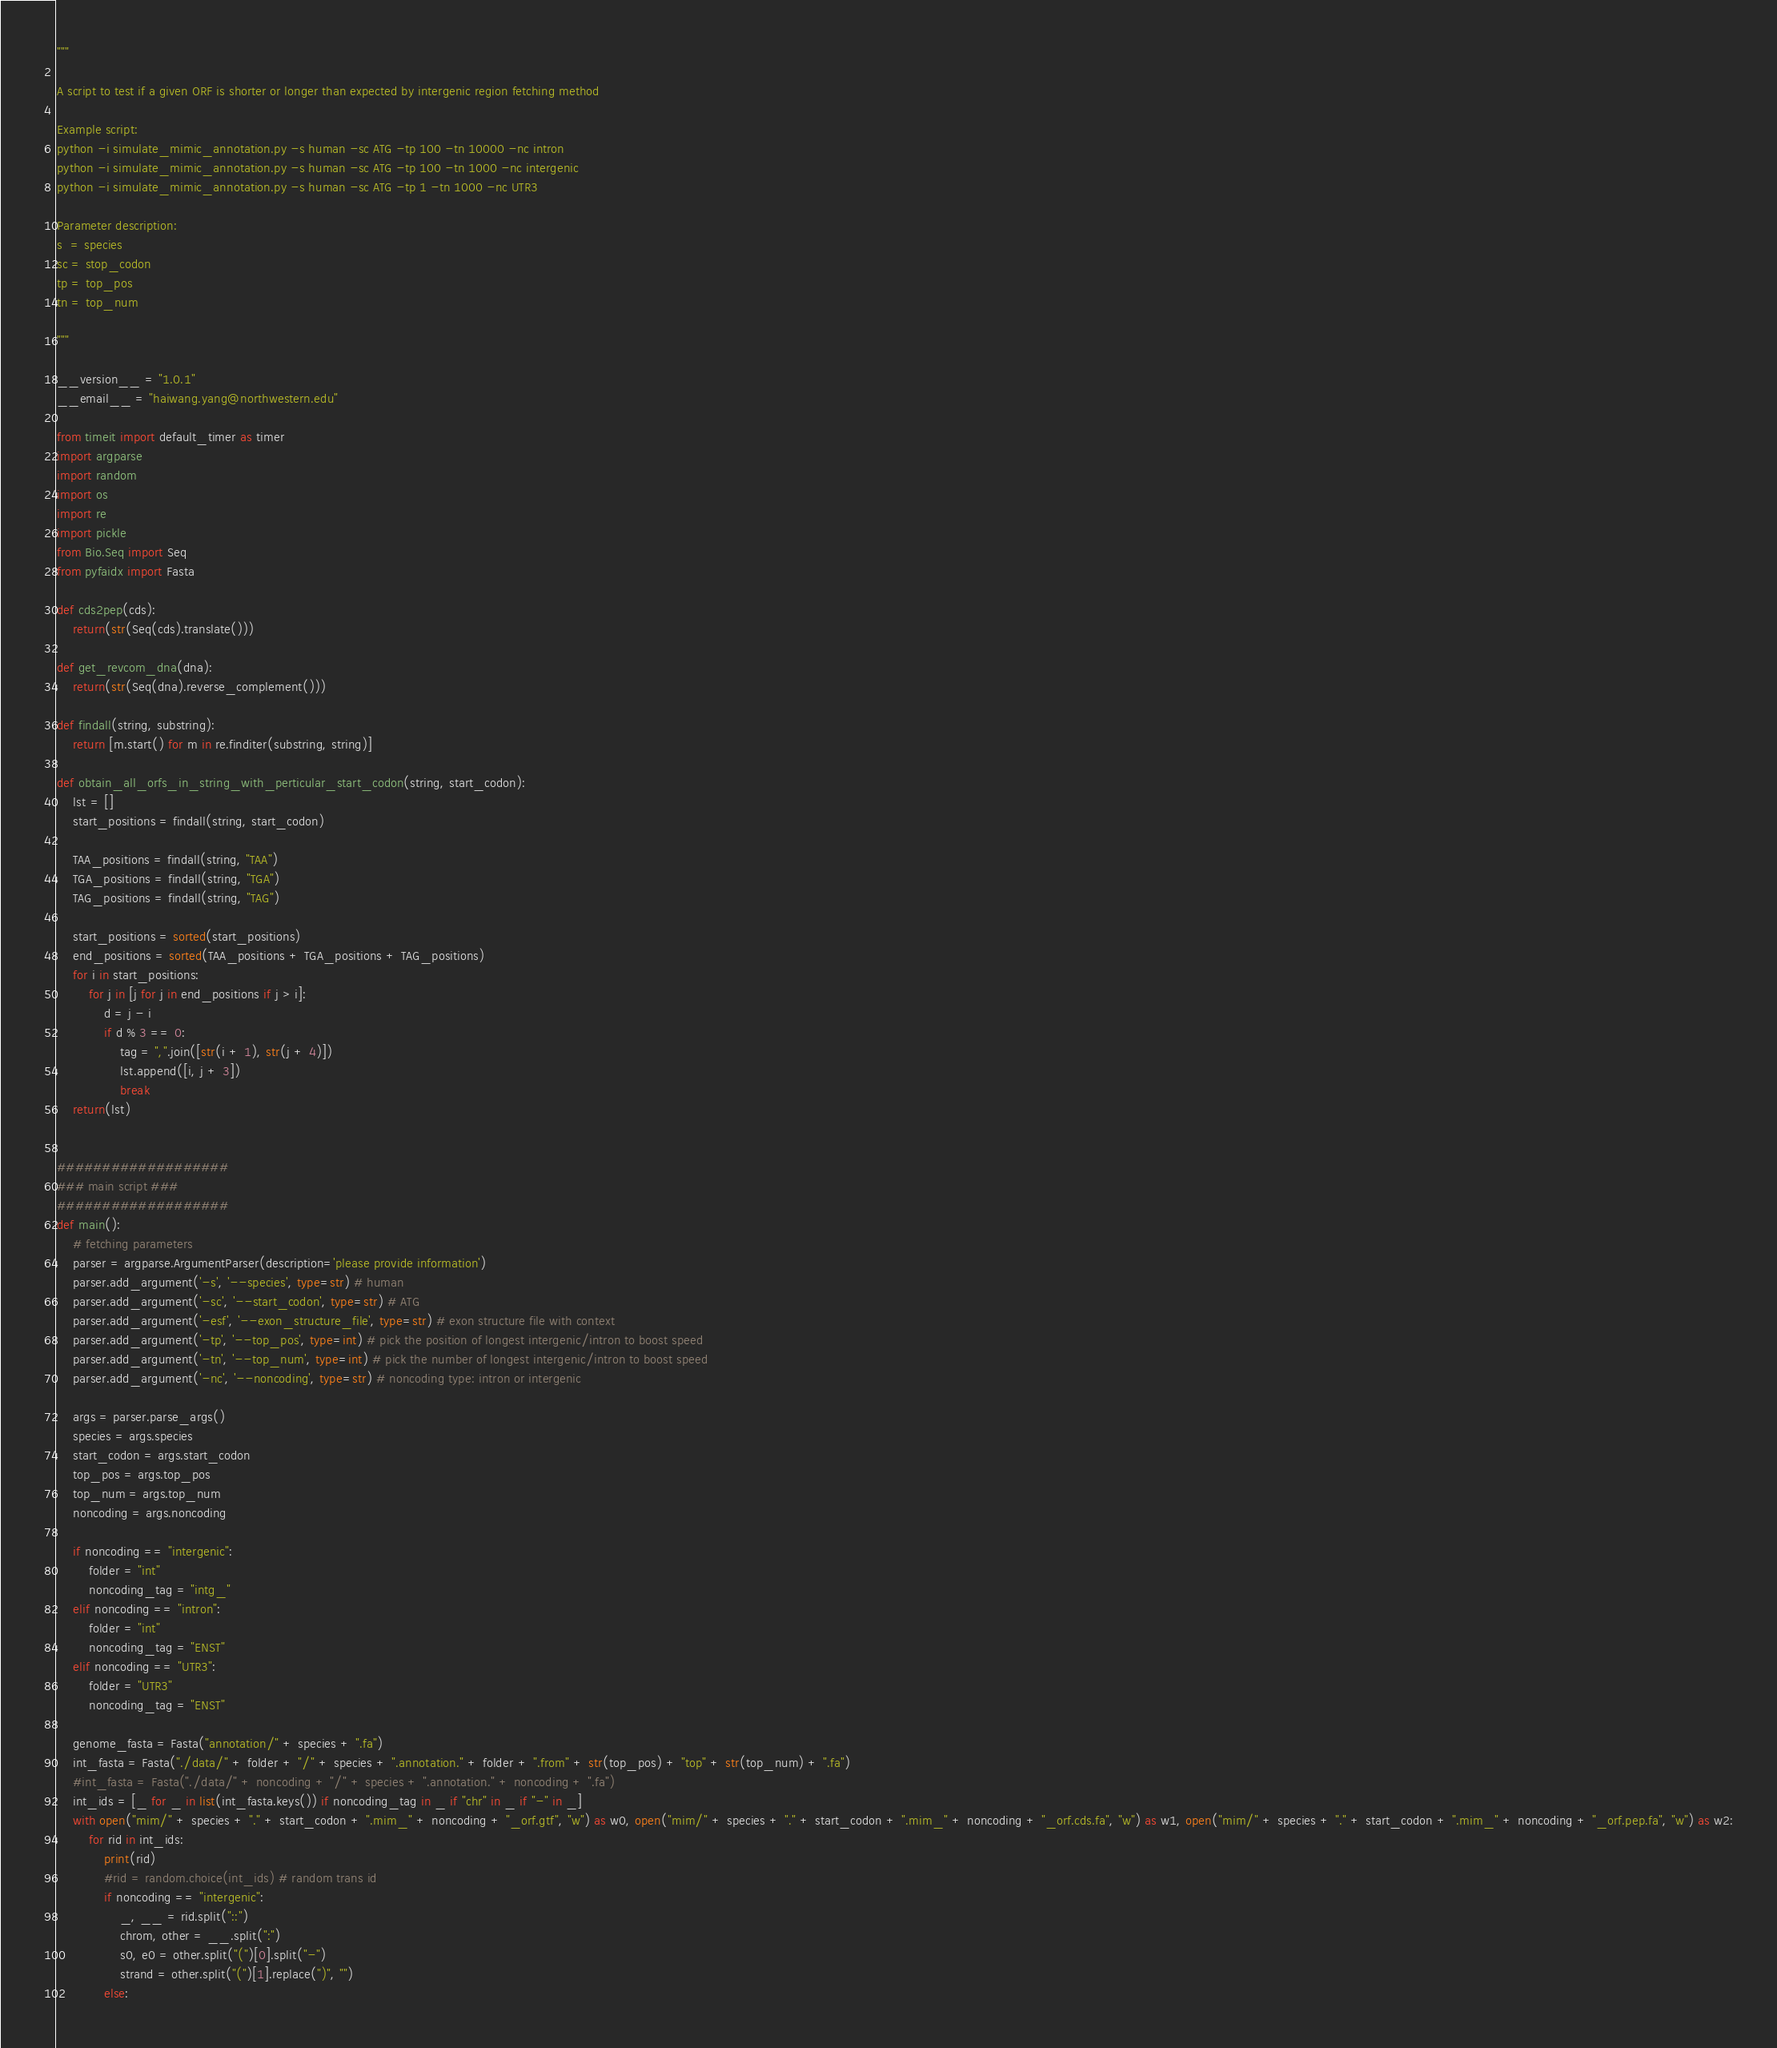Convert code to text. <code><loc_0><loc_0><loc_500><loc_500><_Python_>"""

A script to test if a given ORF is shorter or longer than expected by intergenic region fetching method

Example script:
python -i simulate_mimic_annotation.py -s human -sc ATG -tp 100 -tn 10000 -nc intron
python -i simulate_mimic_annotation.py -s human -sc ATG -tp 100 -tn 1000 -nc intergenic
python -i simulate_mimic_annotation.py -s human -sc ATG -tp 1 -tn 1000 -nc UTR3

Parameter description:
s  = species
sc = stop_codon
tp = top_pos
tn = top_num

"""

__version__ = "1.0.1"
__email__ = "haiwang.yang@northwestern.edu"

from timeit import default_timer as timer
import argparse
import random
import os
import re
import pickle
from Bio.Seq import Seq
from pyfaidx import Fasta

def cds2pep(cds):
    return(str(Seq(cds).translate()))

def get_revcom_dna(dna):
    return(str(Seq(dna).reverse_complement()))

def findall(string, substring):
    return [m.start() for m in re.finditer(substring, string)]

def obtain_all_orfs_in_string_with_perticular_start_codon(string, start_codon):
    lst = []
    start_positions = findall(string, start_codon)

    TAA_positions = findall(string, "TAA")
    TGA_positions = findall(string, "TGA")
    TAG_positions = findall(string, "TAG")

    start_positions = sorted(start_positions)
    end_positions = sorted(TAA_positions + TGA_positions + TAG_positions)
    for i in start_positions:
        for j in [j for j in end_positions if j > i]:
            d = j - i
            if d % 3 == 0:
                tag = ",".join([str(i + 1), str(j + 4)])
                lst.append([i, j + 3])
                break
    return(lst)


###################
### main script ###
###################
def main():
    # fetching parameters
    parser = argparse.ArgumentParser(description='please provide information')
    parser.add_argument('-s', '--species', type=str) # human
    parser.add_argument('-sc', '--start_codon', type=str) # ATG
    parser.add_argument('-esf', '--exon_structure_file', type=str) # exon structure file with context
    parser.add_argument('-tp', '--top_pos', type=int) # pick the position of longest intergenic/intron to boost speed
    parser.add_argument('-tn', '--top_num', type=int) # pick the number of longest intergenic/intron to boost speed
    parser.add_argument('-nc', '--noncoding', type=str) # noncoding type: intron or intergenic

    args = parser.parse_args()
    species = args.species
    start_codon = args.start_codon
    top_pos = args.top_pos
    top_num = args.top_num
    noncoding = args.noncoding

    if noncoding == "intergenic":
        folder = "int"
        noncoding_tag = "intg_"
    elif noncoding == "intron":
        folder = "int"
        noncoding_tag = "ENST"
    elif noncoding == "UTR3":
        folder = "UTR3"
        noncoding_tag = "ENST"

    genome_fasta = Fasta("annotation/" + species + ".fa")
    int_fasta = Fasta("./data/" + folder + "/" + species + ".annotation." + folder + ".from" + str(top_pos) + "top" + str(top_num) + ".fa")
    #int_fasta = Fasta("./data/" + noncoding + "/" + species + ".annotation." + noncoding + ".fa")
    int_ids = [_ for _ in list(int_fasta.keys()) if noncoding_tag in _ if "chr" in _ if "-" in _]
    with open("mim/" + species + "." + start_codon + ".mim_" + noncoding + "_orf.gtf", "w") as w0, open("mim/" + species + "." + start_codon + ".mim_" + noncoding + "_orf.cds.fa", "w") as w1, open("mim/" + species + "." + start_codon + ".mim_" + noncoding + "_orf.pep.fa", "w") as w2:
        for rid in int_ids:
            print(rid)
            #rid = random.choice(int_ids) # random trans id
            if noncoding == "intergenic":
                _, __ = rid.split("::")
                chrom, other = __.split(":")
                s0, e0 = other.split("(")[0].split("-")
                strand = other.split("(")[1].replace(")", "")
            else:</code> 